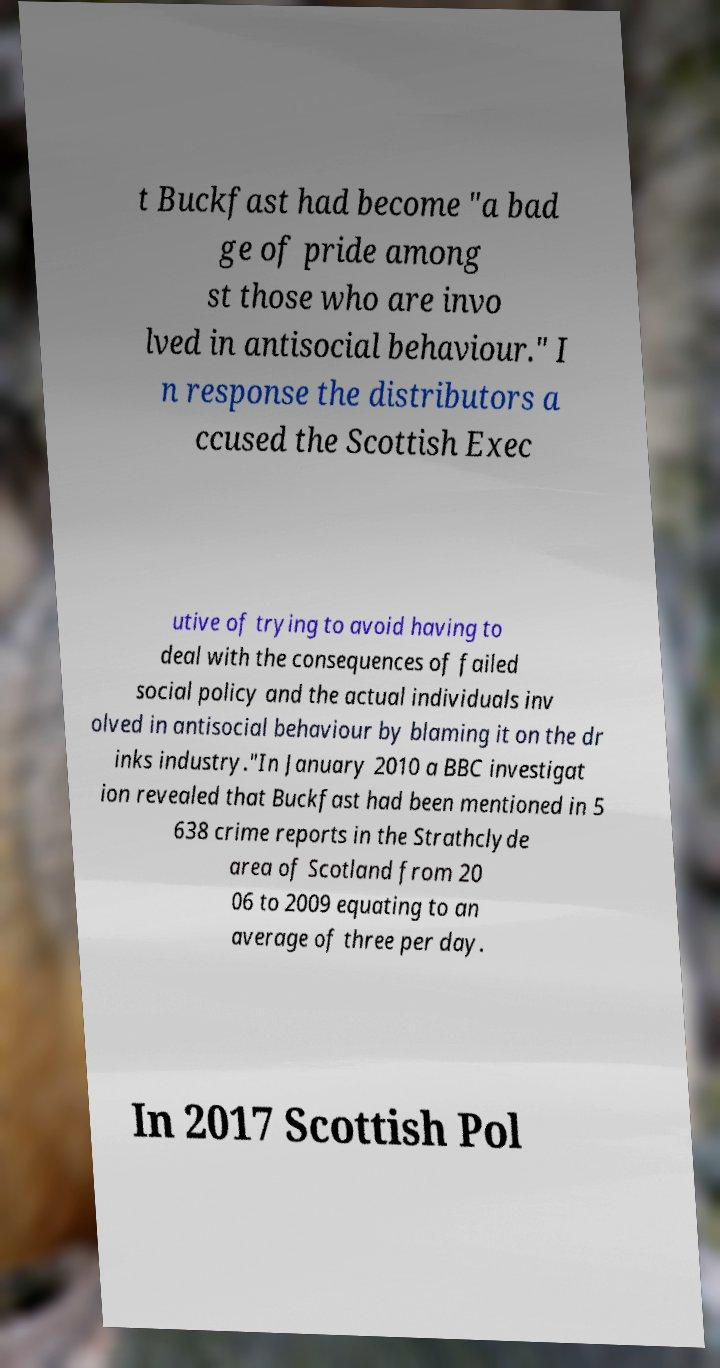Could you extract and type out the text from this image? t Buckfast had become "a bad ge of pride among st those who are invo lved in antisocial behaviour." I n response the distributors a ccused the Scottish Exec utive of trying to avoid having to deal with the consequences of failed social policy and the actual individuals inv olved in antisocial behaviour by blaming it on the dr inks industry."In January 2010 a BBC investigat ion revealed that Buckfast had been mentioned in 5 638 crime reports in the Strathclyde area of Scotland from 20 06 to 2009 equating to an average of three per day. In 2017 Scottish Pol 